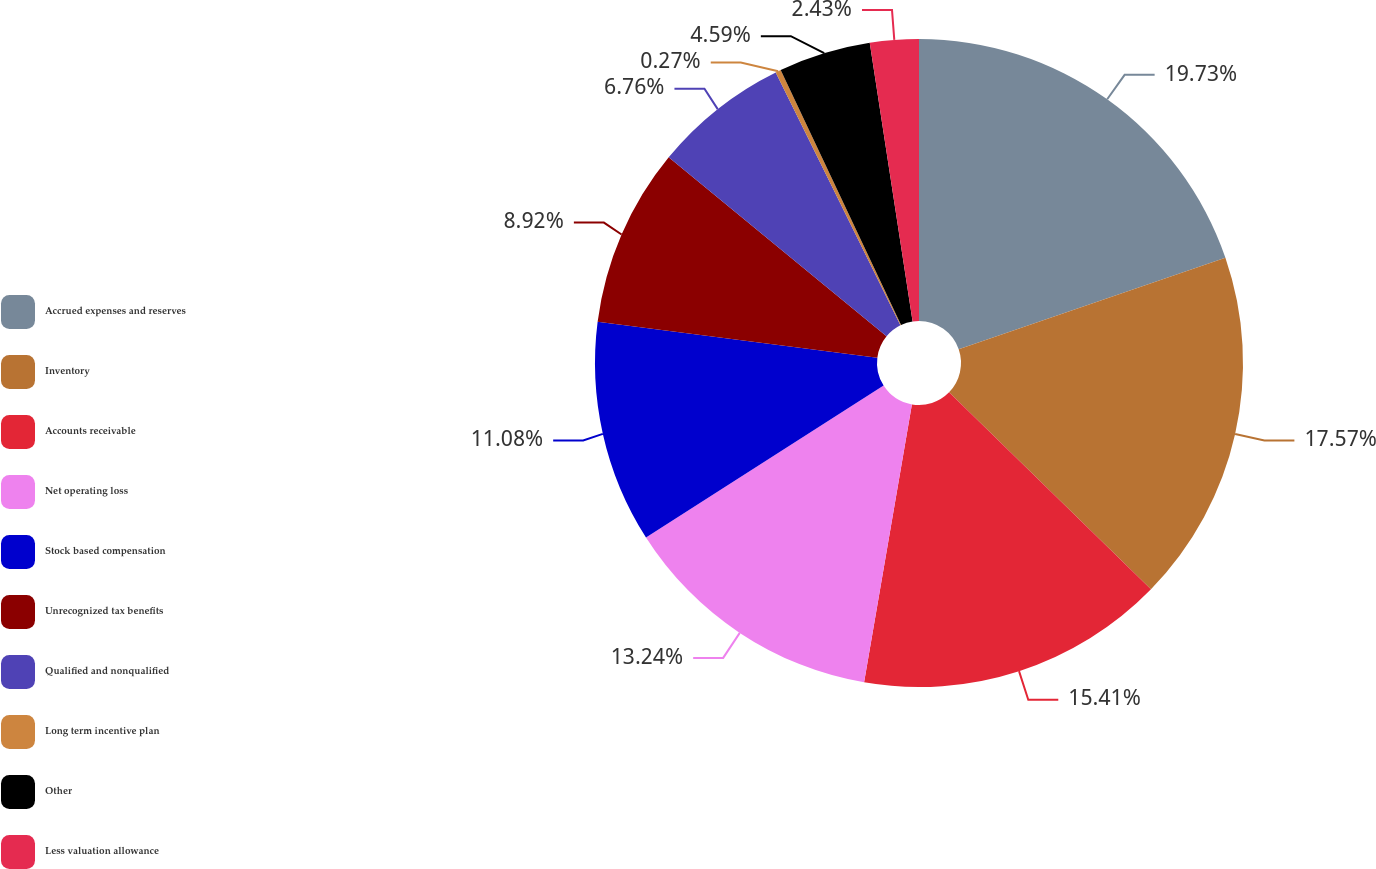Convert chart. <chart><loc_0><loc_0><loc_500><loc_500><pie_chart><fcel>Accrued expenses and reserves<fcel>Inventory<fcel>Accounts receivable<fcel>Net operating loss<fcel>Stock based compensation<fcel>Unrecognized tax benefits<fcel>Qualified and nonqualified<fcel>Long term incentive plan<fcel>Other<fcel>Less valuation allowance<nl><fcel>19.73%<fcel>17.57%<fcel>15.41%<fcel>13.24%<fcel>11.08%<fcel>8.92%<fcel>6.76%<fcel>0.27%<fcel>4.59%<fcel>2.43%<nl></chart> 